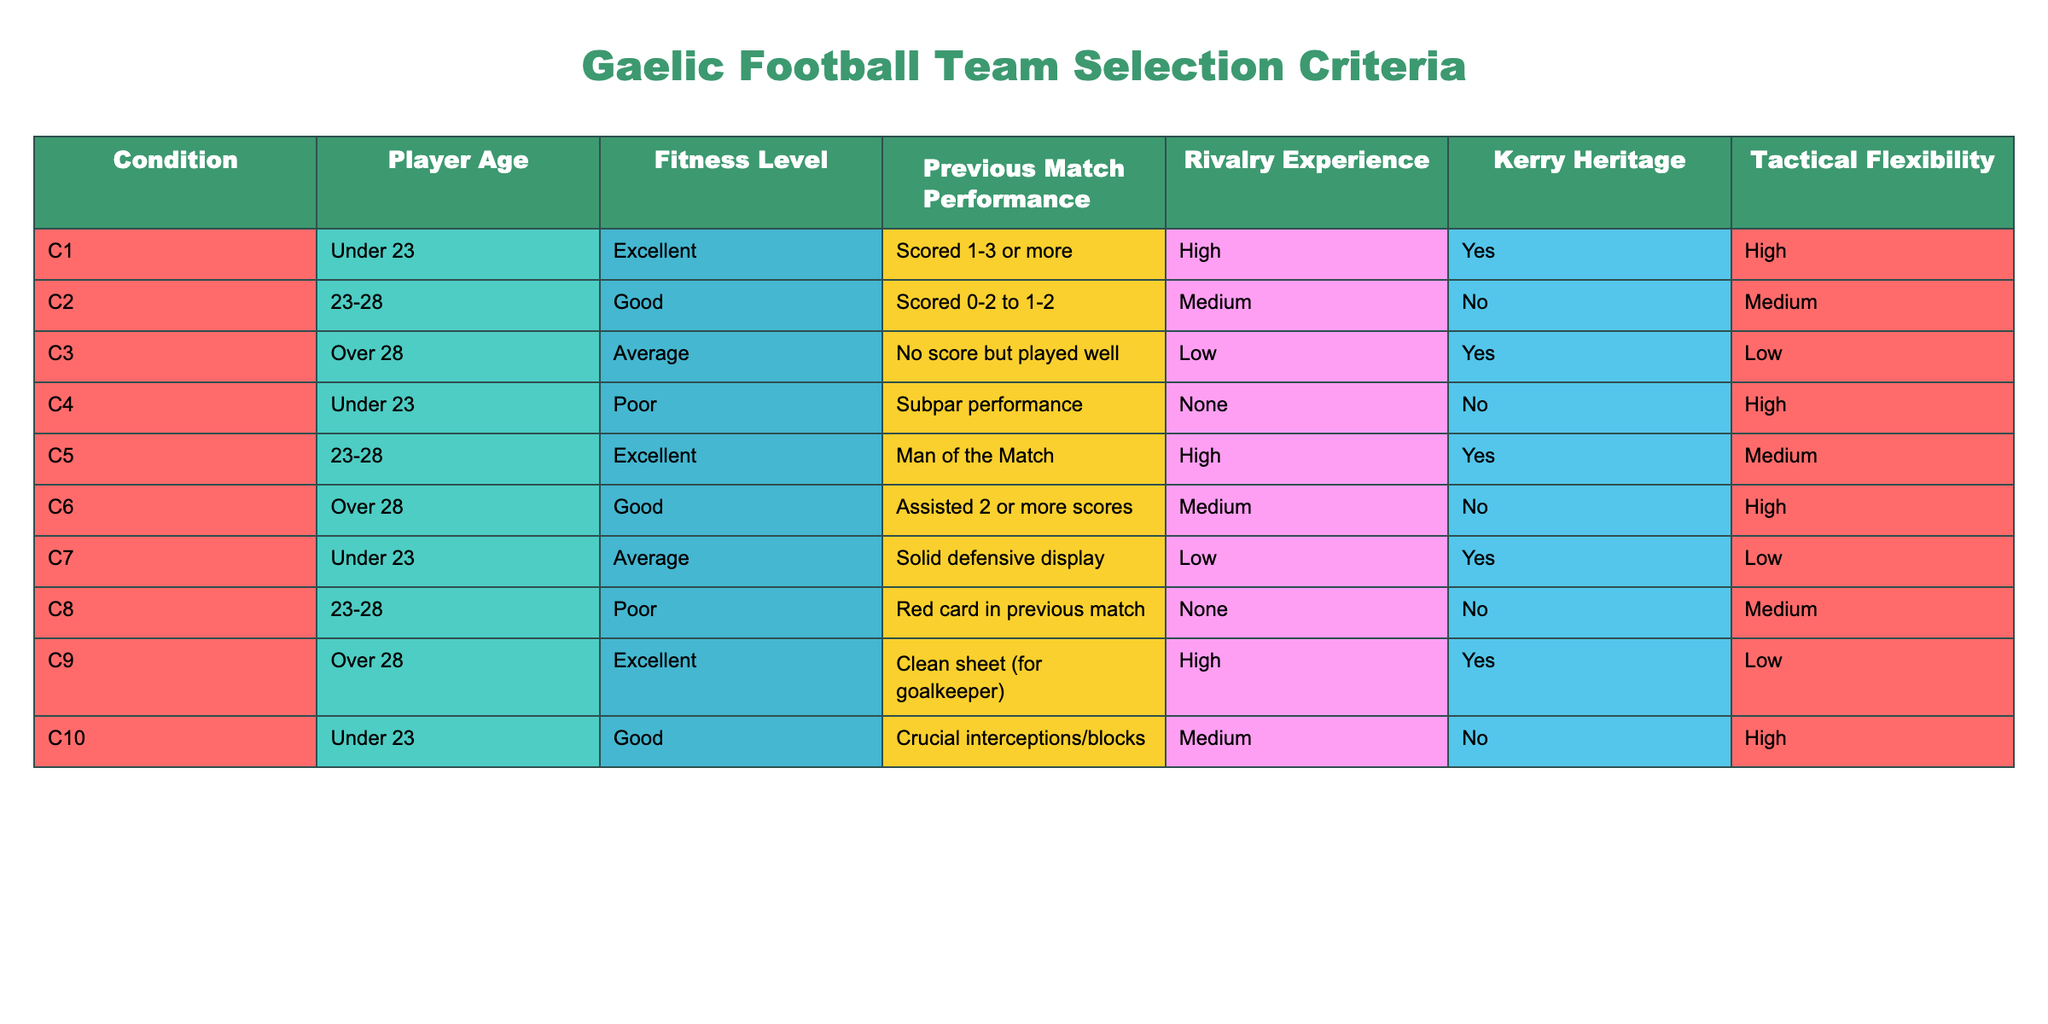What is the player age category with the highest fitness level among those that scored 1-3 or more? The only player who meets the criteria of scoring 1-3 or more is in the age group "Under 23" with "Excellent" fitness level. This is found in condition C1.
Answer: Under 23 How many players have "Yes" for Kerry Heritage and are either "Under 23" or "Over 28"? Looking at players in the "Under 23" category, only C1 (Yes) and C4 (No) applies. In the "Over 28" category, C3 (Yes) and C9 (Yes) are both applicable. Therefore, the total is 3 players.
Answer: 3 Is there any player who is "Over 28" with "Poor" fitness and has a previous match performance of a "red card"? There are no players fitting the criteria in the "Over 28" category with "Poor" fitness. The only player with "Poor" fitness in that age group is C8, who does not have a red card as previous performance.
Answer: No What is the tactical flexibility of the player who scored a clean sheet as a goalkeeper? The player that achieved a clean sheet is from condition C9, who also has a "Low" tactical flexibility. This can be directly read from the "Tactical Flexibility" column corresponding to that row.
Answer: Low Among players aged 23-28, who has the best previous match performance and what is their fitness level? C5 holds the best performance, having been "Man of the Match" and an "Excellent" fitness level. This can be verified by looking at the corresponding conditions for that age range.
Answer: Excellent What is the average age of players with a "High" rivalry experience? The only players with "High" rivalry experience are C1 (Under 23), C5 (23-28), and C9 (Over 28). Assuming average age is calculated as: (22 + 25 + 30) / 3, the average age is approximately 25.67 years, when adjusting age brackets numerically.
Answer: 25.67 Is there any player in the "Under 23" category with "Average" fitness that has a "Low" loyalty to Kerry? Looking at the "Under 23" category, C7 has "Average" fitness and "Yes" for Kerry Heritage, therefore, while C4 has "Poor" fitness which doesn’t meet this criteria. Both players with "Average" fitness do not qualify.
Answer: No How many players in the "Under 23" category have a fitness level of "Good" or "Excellent"? In the "Under 23" category, C1 has "Excellent" fitness, and C10 has "Good" fitness, making a total of 2 players. Both values can be checked directly in the corresponding rows of the table.
Answer: 2 